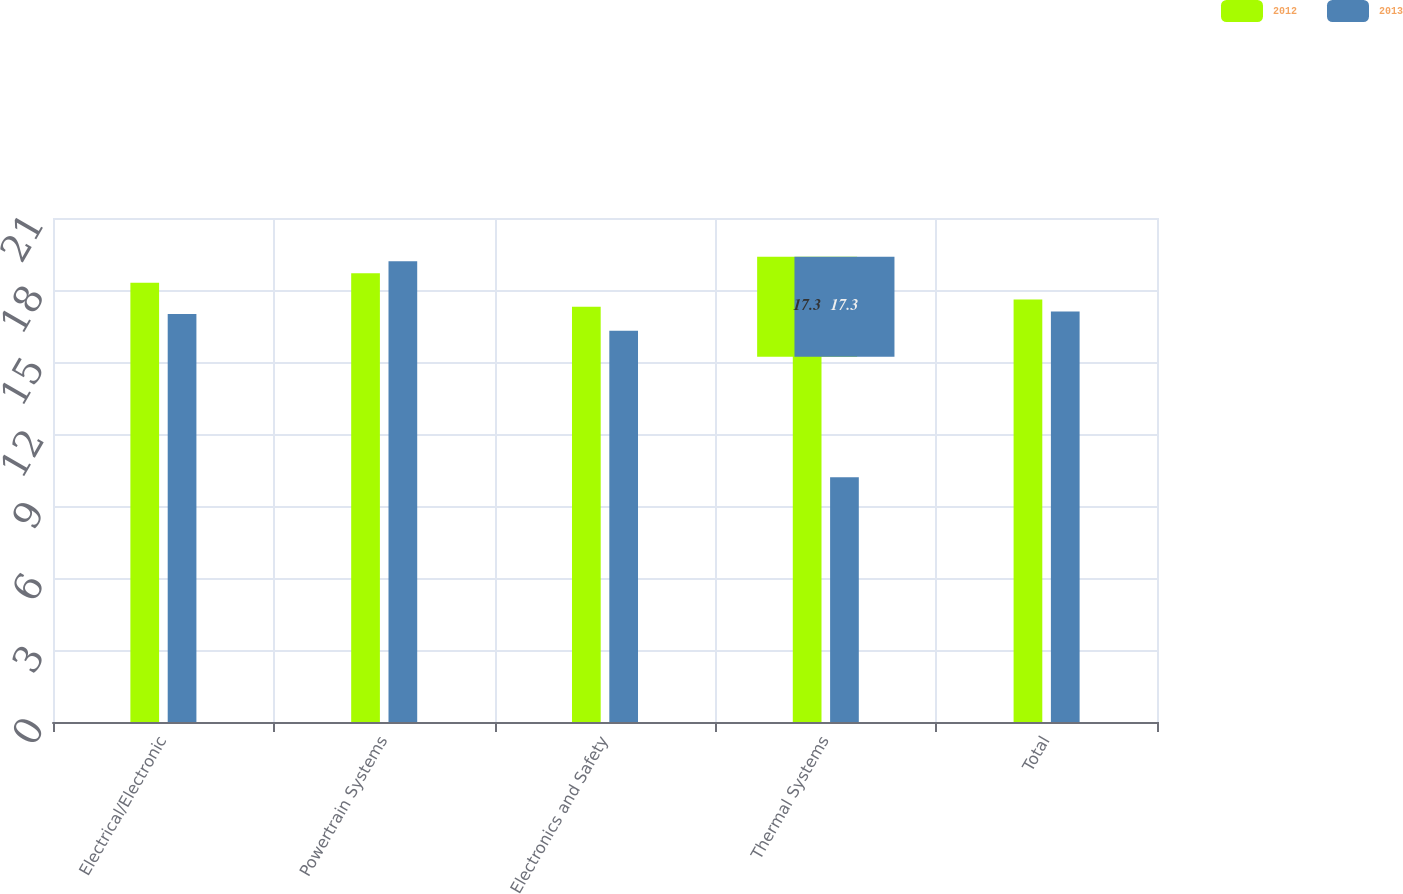Convert chart. <chart><loc_0><loc_0><loc_500><loc_500><stacked_bar_chart><ecel><fcel>Electrical/Electronic<fcel>Powertrain Systems<fcel>Electronics and Safety<fcel>Thermal Systems<fcel>Total<nl><fcel>2012<fcel>18.3<fcel>18.7<fcel>17.3<fcel>17.3<fcel>17.6<nl><fcel>2013<fcel>17<fcel>19.2<fcel>16.3<fcel>10.2<fcel>17.1<nl></chart> 